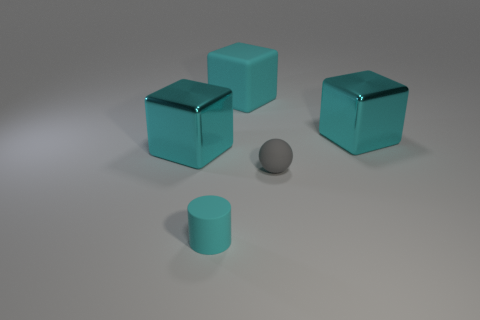There is a large matte thing that is the same color as the tiny matte cylinder; what is its shape?
Provide a succinct answer. Cube. There is a big metal object to the right of the tiny gray ball; is its color the same as the metallic cube to the left of the tiny gray thing?
Give a very brief answer. Yes. Is there a rubber block of the same color as the cylinder?
Offer a terse response. Yes. What size is the matte cube that is the same color as the matte cylinder?
Ensure brevity in your answer.  Large. How many metal things are the same color as the big matte block?
Your answer should be very brief. 2. Is the number of small spheres right of the small gray object less than the number of big blue rubber objects?
Provide a succinct answer. No. There is a matte ball that is left of the object on the right side of the gray rubber ball; what is its color?
Make the answer very short. Gray. There is a cyan object in front of the cyan shiny object that is in front of the large cyan metallic object that is right of the tiny gray sphere; what is its size?
Your response must be concise. Small. Are there fewer metal things to the right of the big cyan matte block than cyan objects that are behind the small cylinder?
Provide a short and direct response. Yes. How many gray spheres have the same material as the tiny cylinder?
Keep it short and to the point. 1. 